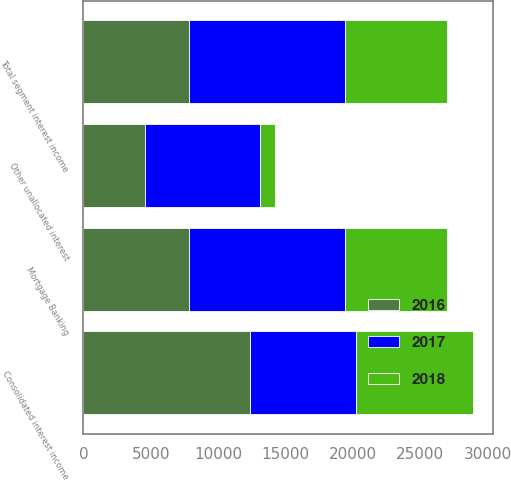Convert chart. <chart><loc_0><loc_0><loc_500><loc_500><stacked_bar_chart><ecel><fcel>Mortgage Banking<fcel>Total segment interest income<fcel>Other unallocated interest<fcel>Consolidated interest income<nl><fcel>2017<fcel>11593<fcel>11593<fcel>8588<fcel>7850<nl><fcel>2016<fcel>7850<fcel>7850<fcel>4554<fcel>12404<nl><fcel>2018<fcel>7569<fcel>7569<fcel>1111<fcel>8680<nl></chart> 